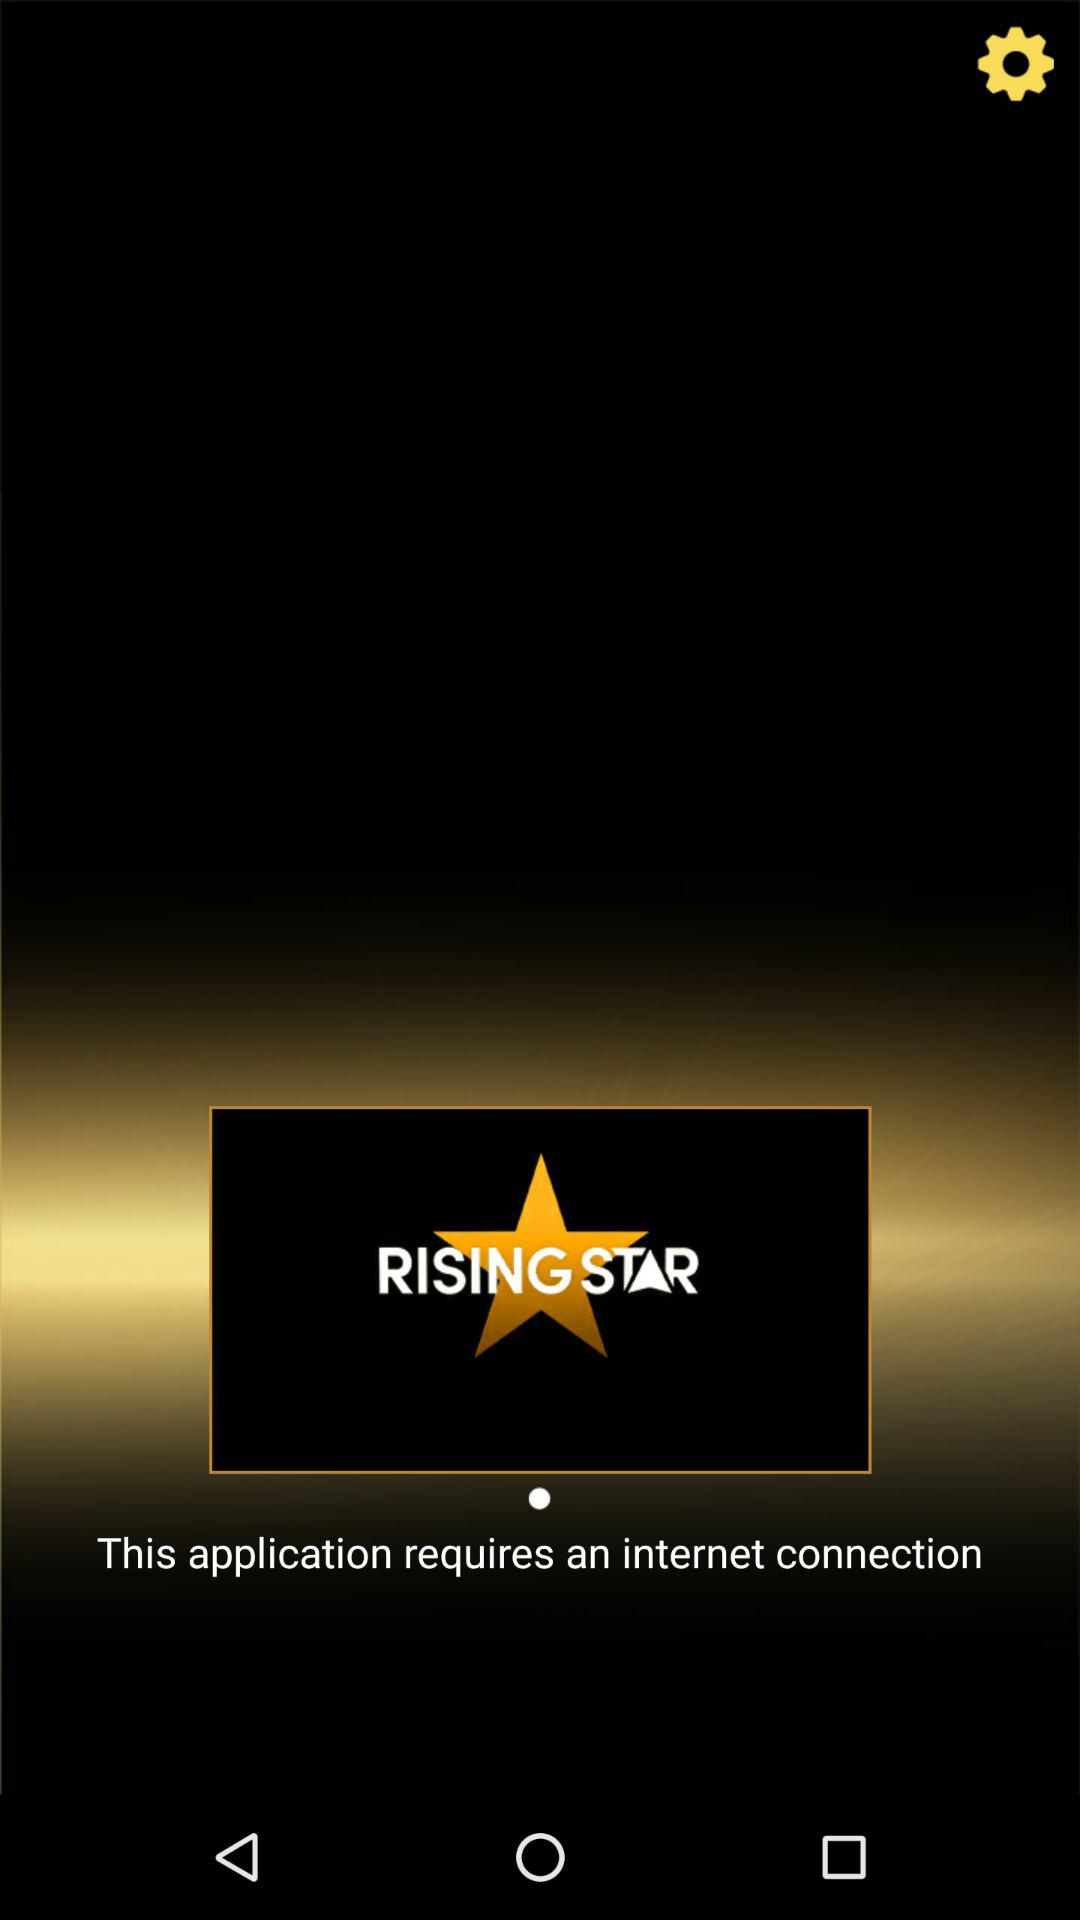What is the application name? The application name is "RISING STAR". 